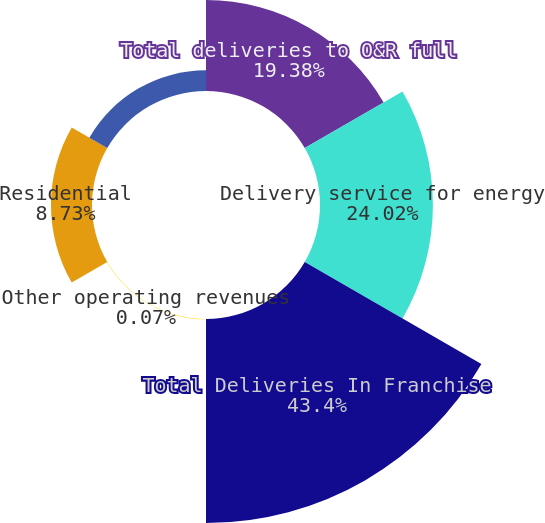Convert chart to OTSL. <chart><loc_0><loc_0><loc_500><loc_500><pie_chart><fcel>Total deliveries to O&R full<fcel>Delivery service for energy<fcel>Total Deliveries In Franchise<fcel>Other operating revenues<fcel>Residential<fcel>Commercial and Industrial<nl><fcel>19.38%<fcel>24.02%<fcel>43.4%<fcel>0.07%<fcel>8.73%<fcel>4.4%<nl></chart> 